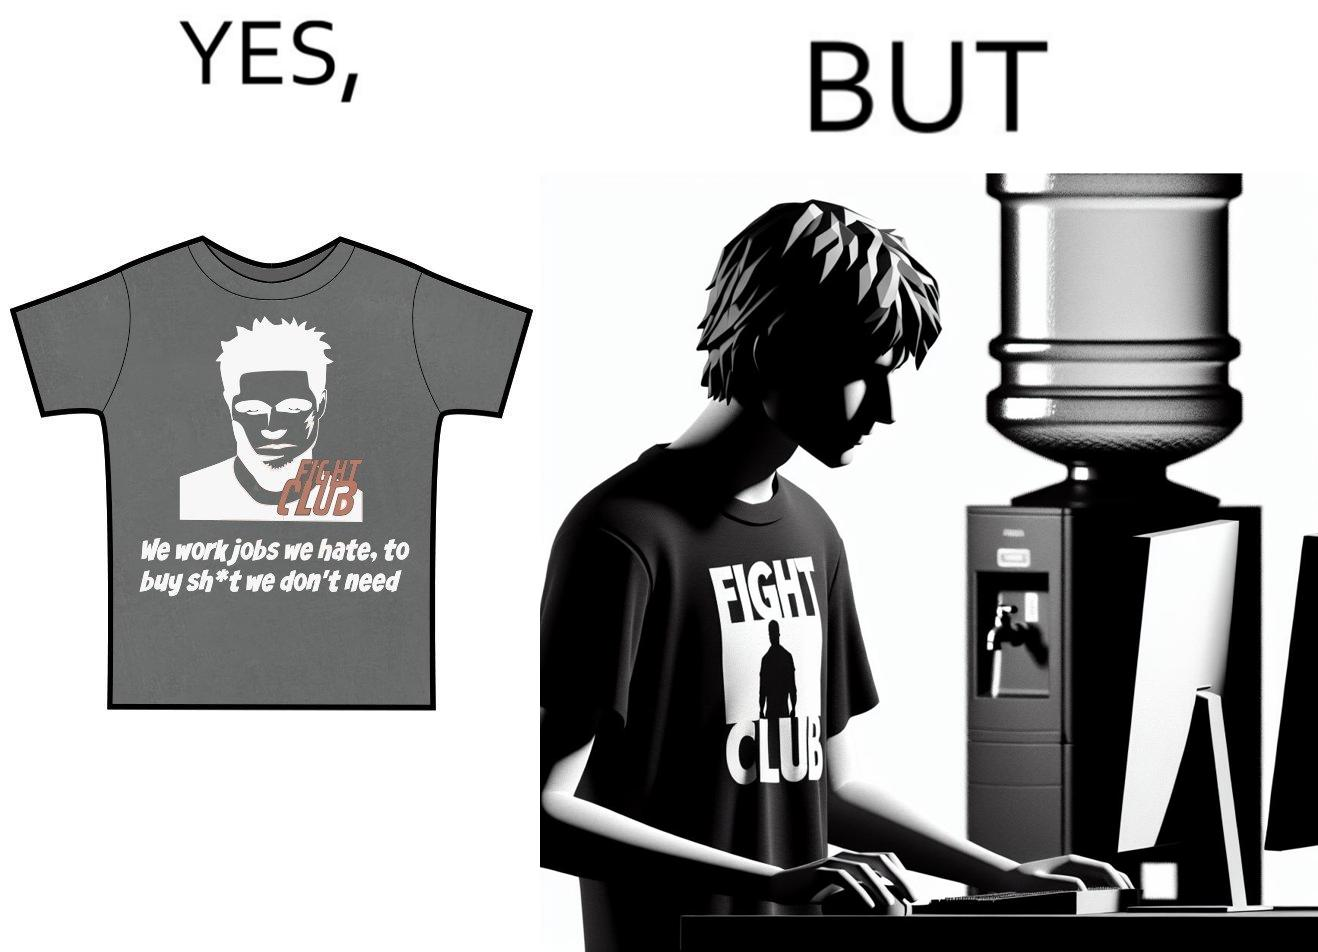Is there satirical content in this image? Yes, this image is satirical. 